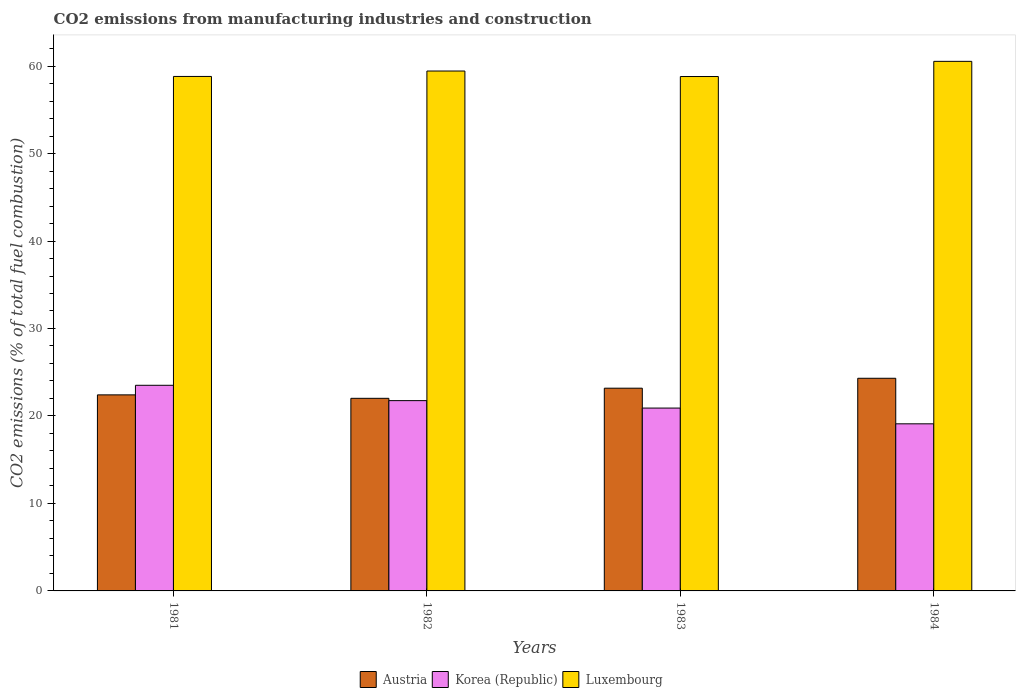How many different coloured bars are there?
Provide a short and direct response. 3. Are the number of bars on each tick of the X-axis equal?
Ensure brevity in your answer.  Yes. How many bars are there on the 2nd tick from the left?
Offer a very short reply. 3. How many bars are there on the 2nd tick from the right?
Offer a terse response. 3. What is the label of the 4th group of bars from the left?
Make the answer very short. 1984. What is the amount of CO2 emitted in Austria in 1983?
Give a very brief answer. 23.17. Across all years, what is the maximum amount of CO2 emitted in Luxembourg?
Provide a short and direct response. 60.54. Across all years, what is the minimum amount of CO2 emitted in Austria?
Your answer should be compact. 22.02. In which year was the amount of CO2 emitted in Luxembourg maximum?
Ensure brevity in your answer.  1984. What is the total amount of CO2 emitted in Korea (Republic) in the graph?
Keep it short and to the point. 85.26. What is the difference between the amount of CO2 emitted in Luxembourg in 1982 and that in 1983?
Offer a terse response. 0.63. What is the difference between the amount of CO2 emitted in Austria in 1983 and the amount of CO2 emitted in Korea (Republic) in 1984?
Your answer should be compact. 4.07. What is the average amount of CO2 emitted in Korea (Republic) per year?
Offer a very short reply. 21.32. In the year 1983, what is the difference between the amount of CO2 emitted in Luxembourg and amount of CO2 emitted in Austria?
Provide a short and direct response. 35.63. What is the ratio of the amount of CO2 emitted in Korea (Republic) in 1981 to that in 1983?
Provide a succinct answer. 1.12. Is the difference between the amount of CO2 emitted in Luxembourg in 1982 and 1984 greater than the difference between the amount of CO2 emitted in Austria in 1982 and 1984?
Offer a very short reply. Yes. What is the difference between the highest and the second highest amount of CO2 emitted in Korea (Republic)?
Keep it short and to the point. 1.75. What is the difference between the highest and the lowest amount of CO2 emitted in Korea (Republic)?
Your answer should be compact. 4.4. In how many years, is the amount of CO2 emitted in Luxembourg greater than the average amount of CO2 emitted in Luxembourg taken over all years?
Ensure brevity in your answer.  2. Is the sum of the amount of CO2 emitted in Korea (Republic) in 1983 and 1984 greater than the maximum amount of CO2 emitted in Austria across all years?
Offer a very short reply. Yes. What does the 3rd bar from the left in 1984 represents?
Offer a terse response. Luxembourg. What does the 2nd bar from the right in 1981 represents?
Your answer should be very brief. Korea (Republic). Is it the case that in every year, the sum of the amount of CO2 emitted in Austria and amount of CO2 emitted in Korea (Republic) is greater than the amount of CO2 emitted in Luxembourg?
Your response must be concise. No. How many bars are there?
Offer a terse response. 12. Are all the bars in the graph horizontal?
Your answer should be very brief. No. Are the values on the major ticks of Y-axis written in scientific E-notation?
Make the answer very short. No. Does the graph contain any zero values?
Provide a short and direct response. No. Does the graph contain grids?
Keep it short and to the point. No. How are the legend labels stacked?
Offer a very short reply. Horizontal. What is the title of the graph?
Offer a very short reply. CO2 emissions from manufacturing industries and construction. What is the label or title of the X-axis?
Your response must be concise. Years. What is the label or title of the Y-axis?
Provide a succinct answer. CO2 emissions (% of total fuel combustion). What is the CO2 emissions (% of total fuel combustion) of Austria in 1981?
Offer a very short reply. 22.41. What is the CO2 emissions (% of total fuel combustion) in Korea (Republic) in 1981?
Your answer should be very brief. 23.51. What is the CO2 emissions (% of total fuel combustion) in Luxembourg in 1981?
Offer a very short reply. 58.81. What is the CO2 emissions (% of total fuel combustion) of Austria in 1982?
Offer a very short reply. 22.02. What is the CO2 emissions (% of total fuel combustion) in Korea (Republic) in 1982?
Your answer should be compact. 21.75. What is the CO2 emissions (% of total fuel combustion) of Luxembourg in 1982?
Your answer should be compact. 59.43. What is the CO2 emissions (% of total fuel combustion) of Austria in 1983?
Ensure brevity in your answer.  23.17. What is the CO2 emissions (% of total fuel combustion) of Korea (Republic) in 1983?
Make the answer very short. 20.9. What is the CO2 emissions (% of total fuel combustion) in Luxembourg in 1983?
Make the answer very short. 58.8. What is the CO2 emissions (% of total fuel combustion) in Austria in 1984?
Provide a succinct answer. 24.31. What is the CO2 emissions (% of total fuel combustion) in Korea (Republic) in 1984?
Your answer should be very brief. 19.1. What is the CO2 emissions (% of total fuel combustion) of Luxembourg in 1984?
Provide a short and direct response. 60.54. Across all years, what is the maximum CO2 emissions (% of total fuel combustion) in Austria?
Make the answer very short. 24.31. Across all years, what is the maximum CO2 emissions (% of total fuel combustion) of Korea (Republic)?
Your answer should be very brief. 23.51. Across all years, what is the maximum CO2 emissions (% of total fuel combustion) in Luxembourg?
Your response must be concise. 60.54. Across all years, what is the minimum CO2 emissions (% of total fuel combustion) of Austria?
Your answer should be very brief. 22.02. Across all years, what is the minimum CO2 emissions (% of total fuel combustion) of Korea (Republic)?
Give a very brief answer. 19.1. Across all years, what is the minimum CO2 emissions (% of total fuel combustion) in Luxembourg?
Keep it short and to the point. 58.8. What is the total CO2 emissions (% of total fuel combustion) of Austria in the graph?
Ensure brevity in your answer.  91.91. What is the total CO2 emissions (% of total fuel combustion) of Korea (Republic) in the graph?
Your answer should be compact. 85.26. What is the total CO2 emissions (% of total fuel combustion) in Luxembourg in the graph?
Your answer should be very brief. 237.58. What is the difference between the CO2 emissions (% of total fuel combustion) in Austria in 1981 and that in 1982?
Give a very brief answer. 0.39. What is the difference between the CO2 emissions (% of total fuel combustion) of Korea (Republic) in 1981 and that in 1982?
Give a very brief answer. 1.75. What is the difference between the CO2 emissions (% of total fuel combustion) in Luxembourg in 1981 and that in 1982?
Your answer should be very brief. -0.62. What is the difference between the CO2 emissions (% of total fuel combustion) in Austria in 1981 and that in 1983?
Your response must be concise. -0.76. What is the difference between the CO2 emissions (% of total fuel combustion) of Korea (Republic) in 1981 and that in 1983?
Ensure brevity in your answer.  2.6. What is the difference between the CO2 emissions (% of total fuel combustion) in Luxembourg in 1981 and that in 1983?
Your answer should be compact. 0.01. What is the difference between the CO2 emissions (% of total fuel combustion) of Austria in 1981 and that in 1984?
Your answer should be compact. -1.9. What is the difference between the CO2 emissions (% of total fuel combustion) of Korea (Republic) in 1981 and that in 1984?
Keep it short and to the point. 4.4. What is the difference between the CO2 emissions (% of total fuel combustion) of Luxembourg in 1981 and that in 1984?
Provide a succinct answer. -1.73. What is the difference between the CO2 emissions (% of total fuel combustion) in Austria in 1982 and that in 1983?
Your response must be concise. -1.16. What is the difference between the CO2 emissions (% of total fuel combustion) in Korea (Republic) in 1982 and that in 1983?
Your answer should be very brief. 0.85. What is the difference between the CO2 emissions (% of total fuel combustion) of Luxembourg in 1982 and that in 1983?
Offer a terse response. 0.63. What is the difference between the CO2 emissions (% of total fuel combustion) of Austria in 1982 and that in 1984?
Keep it short and to the point. -2.29. What is the difference between the CO2 emissions (% of total fuel combustion) in Korea (Republic) in 1982 and that in 1984?
Make the answer very short. 2.65. What is the difference between the CO2 emissions (% of total fuel combustion) of Luxembourg in 1982 and that in 1984?
Keep it short and to the point. -1.11. What is the difference between the CO2 emissions (% of total fuel combustion) of Austria in 1983 and that in 1984?
Give a very brief answer. -1.13. What is the difference between the CO2 emissions (% of total fuel combustion) of Korea (Republic) in 1983 and that in 1984?
Your answer should be very brief. 1.8. What is the difference between the CO2 emissions (% of total fuel combustion) of Luxembourg in 1983 and that in 1984?
Provide a short and direct response. -1.73. What is the difference between the CO2 emissions (% of total fuel combustion) of Austria in 1981 and the CO2 emissions (% of total fuel combustion) of Korea (Republic) in 1982?
Provide a succinct answer. 0.66. What is the difference between the CO2 emissions (% of total fuel combustion) in Austria in 1981 and the CO2 emissions (% of total fuel combustion) in Luxembourg in 1982?
Offer a terse response. -37.02. What is the difference between the CO2 emissions (% of total fuel combustion) in Korea (Republic) in 1981 and the CO2 emissions (% of total fuel combustion) in Luxembourg in 1982?
Ensure brevity in your answer.  -35.92. What is the difference between the CO2 emissions (% of total fuel combustion) in Austria in 1981 and the CO2 emissions (% of total fuel combustion) in Korea (Republic) in 1983?
Offer a terse response. 1.51. What is the difference between the CO2 emissions (% of total fuel combustion) of Austria in 1981 and the CO2 emissions (% of total fuel combustion) of Luxembourg in 1983?
Give a very brief answer. -36.39. What is the difference between the CO2 emissions (% of total fuel combustion) in Korea (Republic) in 1981 and the CO2 emissions (% of total fuel combustion) in Luxembourg in 1983?
Provide a short and direct response. -35.3. What is the difference between the CO2 emissions (% of total fuel combustion) of Austria in 1981 and the CO2 emissions (% of total fuel combustion) of Korea (Republic) in 1984?
Offer a very short reply. 3.31. What is the difference between the CO2 emissions (% of total fuel combustion) in Austria in 1981 and the CO2 emissions (% of total fuel combustion) in Luxembourg in 1984?
Make the answer very short. -38.13. What is the difference between the CO2 emissions (% of total fuel combustion) in Korea (Republic) in 1981 and the CO2 emissions (% of total fuel combustion) in Luxembourg in 1984?
Provide a succinct answer. -37.03. What is the difference between the CO2 emissions (% of total fuel combustion) in Austria in 1982 and the CO2 emissions (% of total fuel combustion) in Korea (Republic) in 1983?
Ensure brevity in your answer.  1.11. What is the difference between the CO2 emissions (% of total fuel combustion) in Austria in 1982 and the CO2 emissions (% of total fuel combustion) in Luxembourg in 1983?
Make the answer very short. -36.79. What is the difference between the CO2 emissions (% of total fuel combustion) in Korea (Republic) in 1982 and the CO2 emissions (% of total fuel combustion) in Luxembourg in 1983?
Provide a short and direct response. -37.05. What is the difference between the CO2 emissions (% of total fuel combustion) of Austria in 1982 and the CO2 emissions (% of total fuel combustion) of Korea (Republic) in 1984?
Give a very brief answer. 2.91. What is the difference between the CO2 emissions (% of total fuel combustion) of Austria in 1982 and the CO2 emissions (% of total fuel combustion) of Luxembourg in 1984?
Your answer should be very brief. -38.52. What is the difference between the CO2 emissions (% of total fuel combustion) in Korea (Republic) in 1982 and the CO2 emissions (% of total fuel combustion) in Luxembourg in 1984?
Make the answer very short. -38.78. What is the difference between the CO2 emissions (% of total fuel combustion) of Austria in 1983 and the CO2 emissions (% of total fuel combustion) of Korea (Republic) in 1984?
Make the answer very short. 4.07. What is the difference between the CO2 emissions (% of total fuel combustion) of Austria in 1983 and the CO2 emissions (% of total fuel combustion) of Luxembourg in 1984?
Keep it short and to the point. -37.36. What is the difference between the CO2 emissions (% of total fuel combustion) of Korea (Republic) in 1983 and the CO2 emissions (% of total fuel combustion) of Luxembourg in 1984?
Your answer should be compact. -39.63. What is the average CO2 emissions (% of total fuel combustion) in Austria per year?
Your answer should be compact. 22.98. What is the average CO2 emissions (% of total fuel combustion) in Korea (Republic) per year?
Your answer should be compact. 21.32. What is the average CO2 emissions (% of total fuel combustion) in Luxembourg per year?
Ensure brevity in your answer.  59.4. In the year 1981, what is the difference between the CO2 emissions (% of total fuel combustion) in Austria and CO2 emissions (% of total fuel combustion) in Korea (Republic)?
Provide a succinct answer. -1.1. In the year 1981, what is the difference between the CO2 emissions (% of total fuel combustion) of Austria and CO2 emissions (% of total fuel combustion) of Luxembourg?
Offer a very short reply. -36.4. In the year 1981, what is the difference between the CO2 emissions (% of total fuel combustion) of Korea (Republic) and CO2 emissions (% of total fuel combustion) of Luxembourg?
Offer a very short reply. -35.31. In the year 1982, what is the difference between the CO2 emissions (% of total fuel combustion) in Austria and CO2 emissions (% of total fuel combustion) in Korea (Republic)?
Provide a succinct answer. 0.26. In the year 1982, what is the difference between the CO2 emissions (% of total fuel combustion) in Austria and CO2 emissions (% of total fuel combustion) in Luxembourg?
Your answer should be compact. -37.41. In the year 1982, what is the difference between the CO2 emissions (% of total fuel combustion) in Korea (Republic) and CO2 emissions (% of total fuel combustion) in Luxembourg?
Offer a very short reply. -37.68. In the year 1983, what is the difference between the CO2 emissions (% of total fuel combustion) in Austria and CO2 emissions (% of total fuel combustion) in Korea (Republic)?
Provide a short and direct response. 2.27. In the year 1983, what is the difference between the CO2 emissions (% of total fuel combustion) in Austria and CO2 emissions (% of total fuel combustion) in Luxembourg?
Provide a succinct answer. -35.63. In the year 1983, what is the difference between the CO2 emissions (% of total fuel combustion) in Korea (Republic) and CO2 emissions (% of total fuel combustion) in Luxembourg?
Ensure brevity in your answer.  -37.9. In the year 1984, what is the difference between the CO2 emissions (% of total fuel combustion) of Austria and CO2 emissions (% of total fuel combustion) of Korea (Republic)?
Give a very brief answer. 5.21. In the year 1984, what is the difference between the CO2 emissions (% of total fuel combustion) of Austria and CO2 emissions (% of total fuel combustion) of Luxembourg?
Offer a very short reply. -36.23. In the year 1984, what is the difference between the CO2 emissions (% of total fuel combustion) of Korea (Republic) and CO2 emissions (% of total fuel combustion) of Luxembourg?
Provide a succinct answer. -41.43. What is the ratio of the CO2 emissions (% of total fuel combustion) of Austria in 1981 to that in 1982?
Provide a succinct answer. 1.02. What is the ratio of the CO2 emissions (% of total fuel combustion) of Korea (Republic) in 1981 to that in 1982?
Give a very brief answer. 1.08. What is the ratio of the CO2 emissions (% of total fuel combustion) of Luxembourg in 1981 to that in 1982?
Give a very brief answer. 0.99. What is the ratio of the CO2 emissions (% of total fuel combustion) in Austria in 1981 to that in 1983?
Give a very brief answer. 0.97. What is the ratio of the CO2 emissions (% of total fuel combustion) of Korea (Republic) in 1981 to that in 1983?
Make the answer very short. 1.12. What is the ratio of the CO2 emissions (% of total fuel combustion) of Luxembourg in 1981 to that in 1983?
Your answer should be compact. 1. What is the ratio of the CO2 emissions (% of total fuel combustion) of Austria in 1981 to that in 1984?
Provide a short and direct response. 0.92. What is the ratio of the CO2 emissions (% of total fuel combustion) of Korea (Republic) in 1981 to that in 1984?
Your answer should be very brief. 1.23. What is the ratio of the CO2 emissions (% of total fuel combustion) in Luxembourg in 1981 to that in 1984?
Your response must be concise. 0.97. What is the ratio of the CO2 emissions (% of total fuel combustion) of Austria in 1982 to that in 1983?
Give a very brief answer. 0.95. What is the ratio of the CO2 emissions (% of total fuel combustion) in Korea (Republic) in 1982 to that in 1983?
Ensure brevity in your answer.  1.04. What is the ratio of the CO2 emissions (% of total fuel combustion) of Luxembourg in 1982 to that in 1983?
Make the answer very short. 1.01. What is the ratio of the CO2 emissions (% of total fuel combustion) in Austria in 1982 to that in 1984?
Keep it short and to the point. 0.91. What is the ratio of the CO2 emissions (% of total fuel combustion) of Korea (Republic) in 1982 to that in 1984?
Give a very brief answer. 1.14. What is the ratio of the CO2 emissions (% of total fuel combustion) in Luxembourg in 1982 to that in 1984?
Keep it short and to the point. 0.98. What is the ratio of the CO2 emissions (% of total fuel combustion) of Austria in 1983 to that in 1984?
Provide a succinct answer. 0.95. What is the ratio of the CO2 emissions (% of total fuel combustion) in Korea (Republic) in 1983 to that in 1984?
Give a very brief answer. 1.09. What is the ratio of the CO2 emissions (% of total fuel combustion) in Luxembourg in 1983 to that in 1984?
Your answer should be compact. 0.97. What is the difference between the highest and the second highest CO2 emissions (% of total fuel combustion) in Austria?
Ensure brevity in your answer.  1.13. What is the difference between the highest and the second highest CO2 emissions (% of total fuel combustion) in Korea (Republic)?
Keep it short and to the point. 1.75. What is the difference between the highest and the second highest CO2 emissions (% of total fuel combustion) of Luxembourg?
Offer a very short reply. 1.11. What is the difference between the highest and the lowest CO2 emissions (% of total fuel combustion) of Austria?
Ensure brevity in your answer.  2.29. What is the difference between the highest and the lowest CO2 emissions (% of total fuel combustion) of Korea (Republic)?
Your answer should be compact. 4.4. What is the difference between the highest and the lowest CO2 emissions (% of total fuel combustion) of Luxembourg?
Provide a short and direct response. 1.73. 